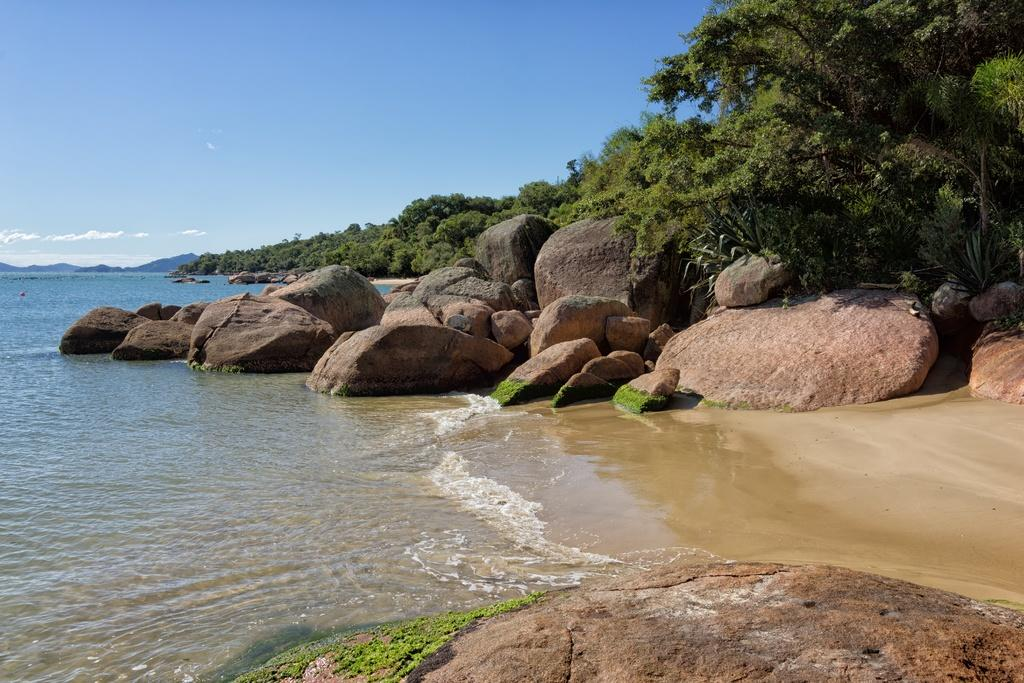What is the primary element in the image? There is water in the image. What can be seen floating in the water? Algae is present in the water. What type of natural objects are visible in the image? Stones and rocks are present in the image. What can be seen in the background of the image? Trees and the sky are visible in the background of the image. What is the condition of the sky in the image? Clouds are present in the sky. How does the stomach feel after eating the rocks in the image? There are no references to eating or stomachs in the image, so it is not possible to answer this question. 